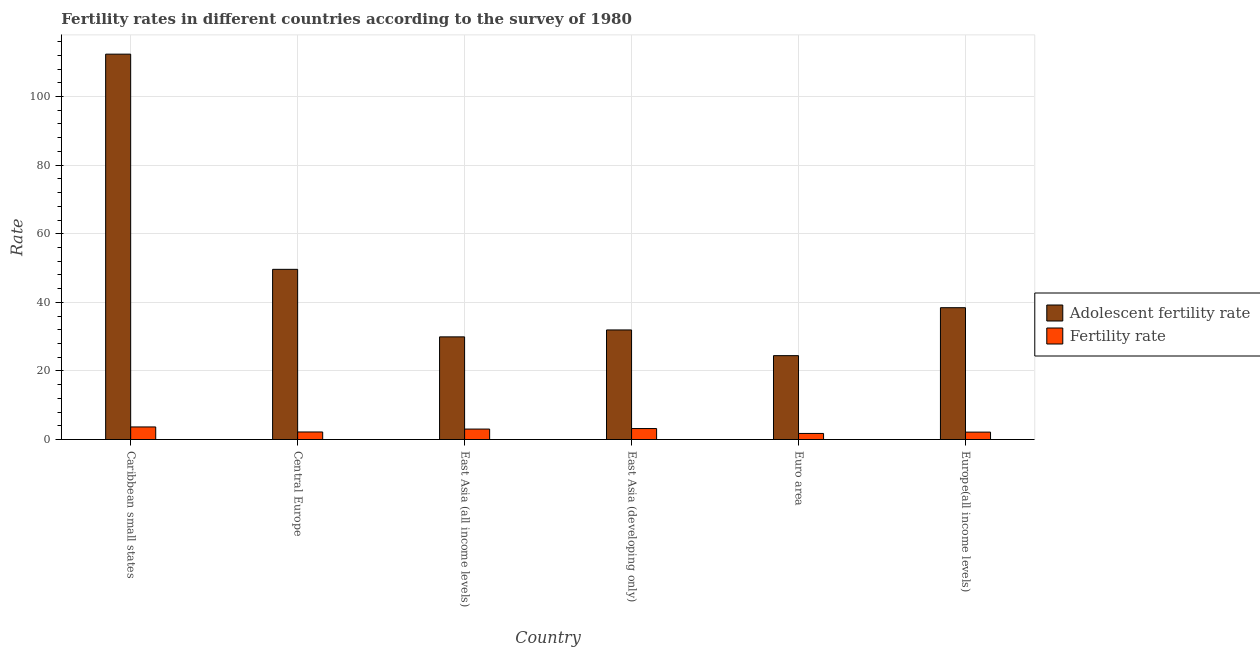How many groups of bars are there?
Your answer should be very brief. 6. Are the number of bars on each tick of the X-axis equal?
Provide a short and direct response. Yes. What is the label of the 2nd group of bars from the left?
Offer a very short reply. Central Europe. In how many cases, is the number of bars for a given country not equal to the number of legend labels?
Your answer should be very brief. 0. What is the fertility rate in Central Europe?
Provide a succinct answer. 2.2. Across all countries, what is the maximum fertility rate?
Provide a succinct answer. 3.67. Across all countries, what is the minimum adolescent fertility rate?
Give a very brief answer. 24.45. In which country was the fertility rate maximum?
Offer a very short reply. Caribbean small states. What is the total fertility rate in the graph?
Offer a terse response. 16.04. What is the difference between the fertility rate in Central Europe and that in Europe(all income levels)?
Make the answer very short. 0.04. What is the difference between the fertility rate in East Asia (developing only) and the adolescent fertility rate in East Asia (all income levels)?
Give a very brief answer. -26.73. What is the average adolescent fertility rate per country?
Offer a very short reply. 47.79. What is the difference between the adolescent fertility rate and fertility rate in Europe(all income levels)?
Your answer should be compact. 36.28. What is the ratio of the adolescent fertility rate in East Asia (developing only) to that in Euro area?
Provide a short and direct response. 1.31. Is the fertility rate in Caribbean small states less than that in East Asia (all income levels)?
Make the answer very short. No. Is the difference between the fertility rate in Caribbean small states and East Asia (all income levels) greater than the difference between the adolescent fertility rate in Caribbean small states and East Asia (all income levels)?
Make the answer very short. No. What is the difference between the highest and the second highest adolescent fertility rate?
Your answer should be compact. 62.74. What is the difference between the highest and the lowest fertility rate?
Offer a terse response. 1.9. What does the 1st bar from the left in Caribbean small states represents?
Make the answer very short. Adolescent fertility rate. What does the 2nd bar from the right in Europe(all income levels) represents?
Offer a very short reply. Adolescent fertility rate. How many countries are there in the graph?
Offer a terse response. 6. Are the values on the major ticks of Y-axis written in scientific E-notation?
Offer a very short reply. No. Does the graph contain any zero values?
Your response must be concise. No. Does the graph contain grids?
Your answer should be very brief. Yes. What is the title of the graph?
Ensure brevity in your answer.  Fertility rates in different countries according to the survey of 1980. What is the label or title of the X-axis?
Your answer should be very brief. Country. What is the label or title of the Y-axis?
Keep it short and to the point. Rate. What is the Rate in Adolescent fertility rate in Caribbean small states?
Your answer should be very brief. 112.36. What is the Rate in Fertility rate in Caribbean small states?
Provide a succinct answer. 3.67. What is the Rate in Adolescent fertility rate in Central Europe?
Give a very brief answer. 49.62. What is the Rate of Fertility rate in Central Europe?
Offer a terse response. 2.2. What is the Rate in Adolescent fertility rate in East Asia (all income levels)?
Offer a very short reply. 29.93. What is the Rate of Fertility rate in East Asia (all income levels)?
Make the answer very short. 3.05. What is the Rate of Adolescent fertility rate in East Asia (developing only)?
Your answer should be very brief. 31.95. What is the Rate of Fertility rate in East Asia (developing only)?
Offer a very short reply. 3.2. What is the Rate in Adolescent fertility rate in Euro area?
Provide a short and direct response. 24.45. What is the Rate in Fertility rate in Euro area?
Ensure brevity in your answer.  1.77. What is the Rate of Adolescent fertility rate in Europe(all income levels)?
Ensure brevity in your answer.  38.44. What is the Rate of Fertility rate in Europe(all income levels)?
Your response must be concise. 2.16. Across all countries, what is the maximum Rate in Adolescent fertility rate?
Offer a terse response. 112.36. Across all countries, what is the maximum Rate in Fertility rate?
Provide a short and direct response. 3.67. Across all countries, what is the minimum Rate of Adolescent fertility rate?
Offer a very short reply. 24.45. Across all countries, what is the minimum Rate in Fertility rate?
Give a very brief answer. 1.77. What is the total Rate of Adolescent fertility rate in the graph?
Make the answer very short. 286.75. What is the total Rate of Fertility rate in the graph?
Your answer should be very brief. 16.04. What is the difference between the Rate of Adolescent fertility rate in Caribbean small states and that in Central Europe?
Your answer should be very brief. 62.74. What is the difference between the Rate in Fertility rate in Caribbean small states and that in Central Europe?
Provide a succinct answer. 1.47. What is the difference between the Rate of Adolescent fertility rate in Caribbean small states and that in East Asia (all income levels)?
Provide a succinct answer. 82.43. What is the difference between the Rate in Fertility rate in Caribbean small states and that in East Asia (all income levels)?
Ensure brevity in your answer.  0.62. What is the difference between the Rate of Adolescent fertility rate in Caribbean small states and that in East Asia (developing only)?
Your answer should be compact. 80.41. What is the difference between the Rate of Fertility rate in Caribbean small states and that in East Asia (developing only)?
Ensure brevity in your answer.  0.47. What is the difference between the Rate in Adolescent fertility rate in Caribbean small states and that in Euro area?
Offer a very short reply. 87.91. What is the difference between the Rate of Fertility rate in Caribbean small states and that in Euro area?
Your response must be concise. 1.9. What is the difference between the Rate in Adolescent fertility rate in Caribbean small states and that in Europe(all income levels)?
Your answer should be compact. 73.92. What is the difference between the Rate in Fertility rate in Caribbean small states and that in Europe(all income levels)?
Give a very brief answer. 1.51. What is the difference between the Rate in Adolescent fertility rate in Central Europe and that in East Asia (all income levels)?
Give a very brief answer. 19.69. What is the difference between the Rate of Fertility rate in Central Europe and that in East Asia (all income levels)?
Make the answer very short. -0.85. What is the difference between the Rate of Adolescent fertility rate in Central Europe and that in East Asia (developing only)?
Make the answer very short. 17.67. What is the difference between the Rate of Fertility rate in Central Europe and that in East Asia (developing only)?
Ensure brevity in your answer.  -1. What is the difference between the Rate in Adolescent fertility rate in Central Europe and that in Euro area?
Your answer should be very brief. 25.16. What is the difference between the Rate of Fertility rate in Central Europe and that in Euro area?
Give a very brief answer. 0.43. What is the difference between the Rate of Adolescent fertility rate in Central Europe and that in Europe(all income levels)?
Keep it short and to the point. 11.18. What is the difference between the Rate in Fertility rate in Central Europe and that in Europe(all income levels)?
Your answer should be compact. 0.04. What is the difference between the Rate of Adolescent fertility rate in East Asia (all income levels) and that in East Asia (developing only)?
Give a very brief answer. -2.02. What is the difference between the Rate in Fertility rate in East Asia (all income levels) and that in East Asia (developing only)?
Your answer should be very brief. -0.15. What is the difference between the Rate in Adolescent fertility rate in East Asia (all income levels) and that in Euro area?
Provide a succinct answer. 5.48. What is the difference between the Rate of Fertility rate in East Asia (all income levels) and that in Euro area?
Your answer should be very brief. 1.27. What is the difference between the Rate of Adolescent fertility rate in East Asia (all income levels) and that in Europe(all income levels)?
Your response must be concise. -8.51. What is the difference between the Rate in Fertility rate in East Asia (all income levels) and that in Europe(all income levels)?
Give a very brief answer. 0.89. What is the difference between the Rate of Adolescent fertility rate in East Asia (developing only) and that in Euro area?
Your answer should be compact. 7.5. What is the difference between the Rate in Fertility rate in East Asia (developing only) and that in Euro area?
Make the answer very short. 1.43. What is the difference between the Rate in Adolescent fertility rate in East Asia (developing only) and that in Europe(all income levels)?
Give a very brief answer. -6.49. What is the difference between the Rate in Fertility rate in East Asia (developing only) and that in Europe(all income levels)?
Provide a short and direct response. 1.04. What is the difference between the Rate in Adolescent fertility rate in Euro area and that in Europe(all income levels)?
Make the answer very short. -13.98. What is the difference between the Rate in Fertility rate in Euro area and that in Europe(all income levels)?
Your answer should be compact. -0.39. What is the difference between the Rate of Adolescent fertility rate in Caribbean small states and the Rate of Fertility rate in Central Europe?
Your answer should be very brief. 110.16. What is the difference between the Rate of Adolescent fertility rate in Caribbean small states and the Rate of Fertility rate in East Asia (all income levels)?
Offer a terse response. 109.32. What is the difference between the Rate in Adolescent fertility rate in Caribbean small states and the Rate in Fertility rate in East Asia (developing only)?
Offer a terse response. 109.16. What is the difference between the Rate in Adolescent fertility rate in Caribbean small states and the Rate in Fertility rate in Euro area?
Give a very brief answer. 110.59. What is the difference between the Rate in Adolescent fertility rate in Caribbean small states and the Rate in Fertility rate in Europe(all income levels)?
Offer a terse response. 110.2. What is the difference between the Rate in Adolescent fertility rate in Central Europe and the Rate in Fertility rate in East Asia (all income levels)?
Your response must be concise. 46.57. What is the difference between the Rate of Adolescent fertility rate in Central Europe and the Rate of Fertility rate in East Asia (developing only)?
Keep it short and to the point. 46.42. What is the difference between the Rate of Adolescent fertility rate in Central Europe and the Rate of Fertility rate in Euro area?
Your response must be concise. 47.85. What is the difference between the Rate of Adolescent fertility rate in Central Europe and the Rate of Fertility rate in Europe(all income levels)?
Offer a very short reply. 47.46. What is the difference between the Rate of Adolescent fertility rate in East Asia (all income levels) and the Rate of Fertility rate in East Asia (developing only)?
Keep it short and to the point. 26.73. What is the difference between the Rate of Adolescent fertility rate in East Asia (all income levels) and the Rate of Fertility rate in Euro area?
Ensure brevity in your answer.  28.16. What is the difference between the Rate of Adolescent fertility rate in East Asia (all income levels) and the Rate of Fertility rate in Europe(all income levels)?
Your response must be concise. 27.77. What is the difference between the Rate in Adolescent fertility rate in East Asia (developing only) and the Rate in Fertility rate in Euro area?
Give a very brief answer. 30.18. What is the difference between the Rate in Adolescent fertility rate in East Asia (developing only) and the Rate in Fertility rate in Europe(all income levels)?
Offer a very short reply. 29.79. What is the difference between the Rate of Adolescent fertility rate in Euro area and the Rate of Fertility rate in Europe(all income levels)?
Provide a succinct answer. 22.29. What is the average Rate in Adolescent fertility rate per country?
Give a very brief answer. 47.79. What is the average Rate in Fertility rate per country?
Your response must be concise. 2.67. What is the difference between the Rate in Adolescent fertility rate and Rate in Fertility rate in Caribbean small states?
Make the answer very short. 108.69. What is the difference between the Rate of Adolescent fertility rate and Rate of Fertility rate in Central Europe?
Give a very brief answer. 47.42. What is the difference between the Rate of Adolescent fertility rate and Rate of Fertility rate in East Asia (all income levels)?
Your answer should be compact. 26.88. What is the difference between the Rate in Adolescent fertility rate and Rate in Fertility rate in East Asia (developing only)?
Provide a succinct answer. 28.75. What is the difference between the Rate of Adolescent fertility rate and Rate of Fertility rate in Euro area?
Offer a very short reply. 22.68. What is the difference between the Rate of Adolescent fertility rate and Rate of Fertility rate in Europe(all income levels)?
Your response must be concise. 36.28. What is the ratio of the Rate in Adolescent fertility rate in Caribbean small states to that in Central Europe?
Provide a succinct answer. 2.26. What is the ratio of the Rate in Fertility rate in Caribbean small states to that in Central Europe?
Your answer should be compact. 1.67. What is the ratio of the Rate in Adolescent fertility rate in Caribbean small states to that in East Asia (all income levels)?
Ensure brevity in your answer.  3.75. What is the ratio of the Rate of Fertility rate in Caribbean small states to that in East Asia (all income levels)?
Provide a succinct answer. 1.2. What is the ratio of the Rate of Adolescent fertility rate in Caribbean small states to that in East Asia (developing only)?
Your answer should be very brief. 3.52. What is the ratio of the Rate of Fertility rate in Caribbean small states to that in East Asia (developing only)?
Make the answer very short. 1.15. What is the ratio of the Rate in Adolescent fertility rate in Caribbean small states to that in Euro area?
Give a very brief answer. 4.59. What is the ratio of the Rate in Fertility rate in Caribbean small states to that in Euro area?
Offer a terse response. 2.07. What is the ratio of the Rate in Adolescent fertility rate in Caribbean small states to that in Europe(all income levels)?
Ensure brevity in your answer.  2.92. What is the ratio of the Rate in Fertility rate in Caribbean small states to that in Europe(all income levels)?
Your answer should be very brief. 1.7. What is the ratio of the Rate of Adolescent fertility rate in Central Europe to that in East Asia (all income levels)?
Your response must be concise. 1.66. What is the ratio of the Rate of Fertility rate in Central Europe to that in East Asia (all income levels)?
Ensure brevity in your answer.  0.72. What is the ratio of the Rate in Adolescent fertility rate in Central Europe to that in East Asia (developing only)?
Offer a terse response. 1.55. What is the ratio of the Rate in Fertility rate in Central Europe to that in East Asia (developing only)?
Provide a succinct answer. 0.69. What is the ratio of the Rate of Adolescent fertility rate in Central Europe to that in Euro area?
Offer a terse response. 2.03. What is the ratio of the Rate in Fertility rate in Central Europe to that in Euro area?
Provide a short and direct response. 1.24. What is the ratio of the Rate in Adolescent fertility rate in Central Europe to that in Europe(all income levels)?
Your answer should be very brief. 1.29. What is the ratio of the Rate of Fertility rate in Central Europe to that in Europe(all income levels)?
Your response must be concise. 1.02. What is the ratio of the Rate in Adolescent fertility rate in East Asia (all income levels) to that in East Asia (developing only)?
Provide a short and direct response. 0.94. What is the ratio of the Rate in Fertility rate in East Asia (all income levels) to that in East Asia (developing only)?
Your response must be concise. 0.95. What is the ratio of the Rate of Adolescent fertility rate in East Asia (all income levels) to that in Euro area?
Offer a terse response. 1.22. What is the ratio of the Rate in Fertility rate in East Asia (all income levels) to that in Euro area?
Offer a terse response. 1.72. What is the ratio of the Rate of Adolescent fertility rate in East Asia (all income levels) to that in Europe(all income levels)?
Your response must be concise. 0.78. What is the ratio of the Rate of Fertility rate in East Asia (all income levels) to that in Europe(all income levels)?
Offer a very short reply. 1.41. What is the ratio of the Rate in Adolescent fertility rate in East Asia (developing only) to that in Euro area?
Offer a terse response. 1.31. What is the ratio of the Rate in Fertility rate in East Asia (developing only) to that in Euro area?
Provide a succinct answer. 1.8. What is the ratio of the Rate in Adolescent fertility rate in East Asia (developing only) to that in Europe(all income levels)?
Provide a succinct answer. 0.83. What is the ratio of the Rate in Fertility rate in East Asia (developing only) to that in Europe(all income levels)?
Provide a short and direct response. 1.48. What is the ratio of the Rate in Adolescent fertility rate in Euro area to that in Europe(all income levels)?
Give a very brief answer. 0.64. What is the ratio of the Rate of Fertility rate in Euro area to that in Europe(all income levels)?
Your response must be concise. 0.82. What is the difference between the highest and the second highest Rate of Adolescent fertility rate?
Your response must be concise. 62.74. What is the difference between the highest and the second highest Rate in Fertility rate?
Offer a very short reply. 0.47. What is the difference between the highest and the lowest Rate of Adolescent fertility rate?
Your answer should be very brief. 87.91. What is the difference between the highest and the lowest Rate in Fertility rate?
Your answer should be very brief. 1.9. 